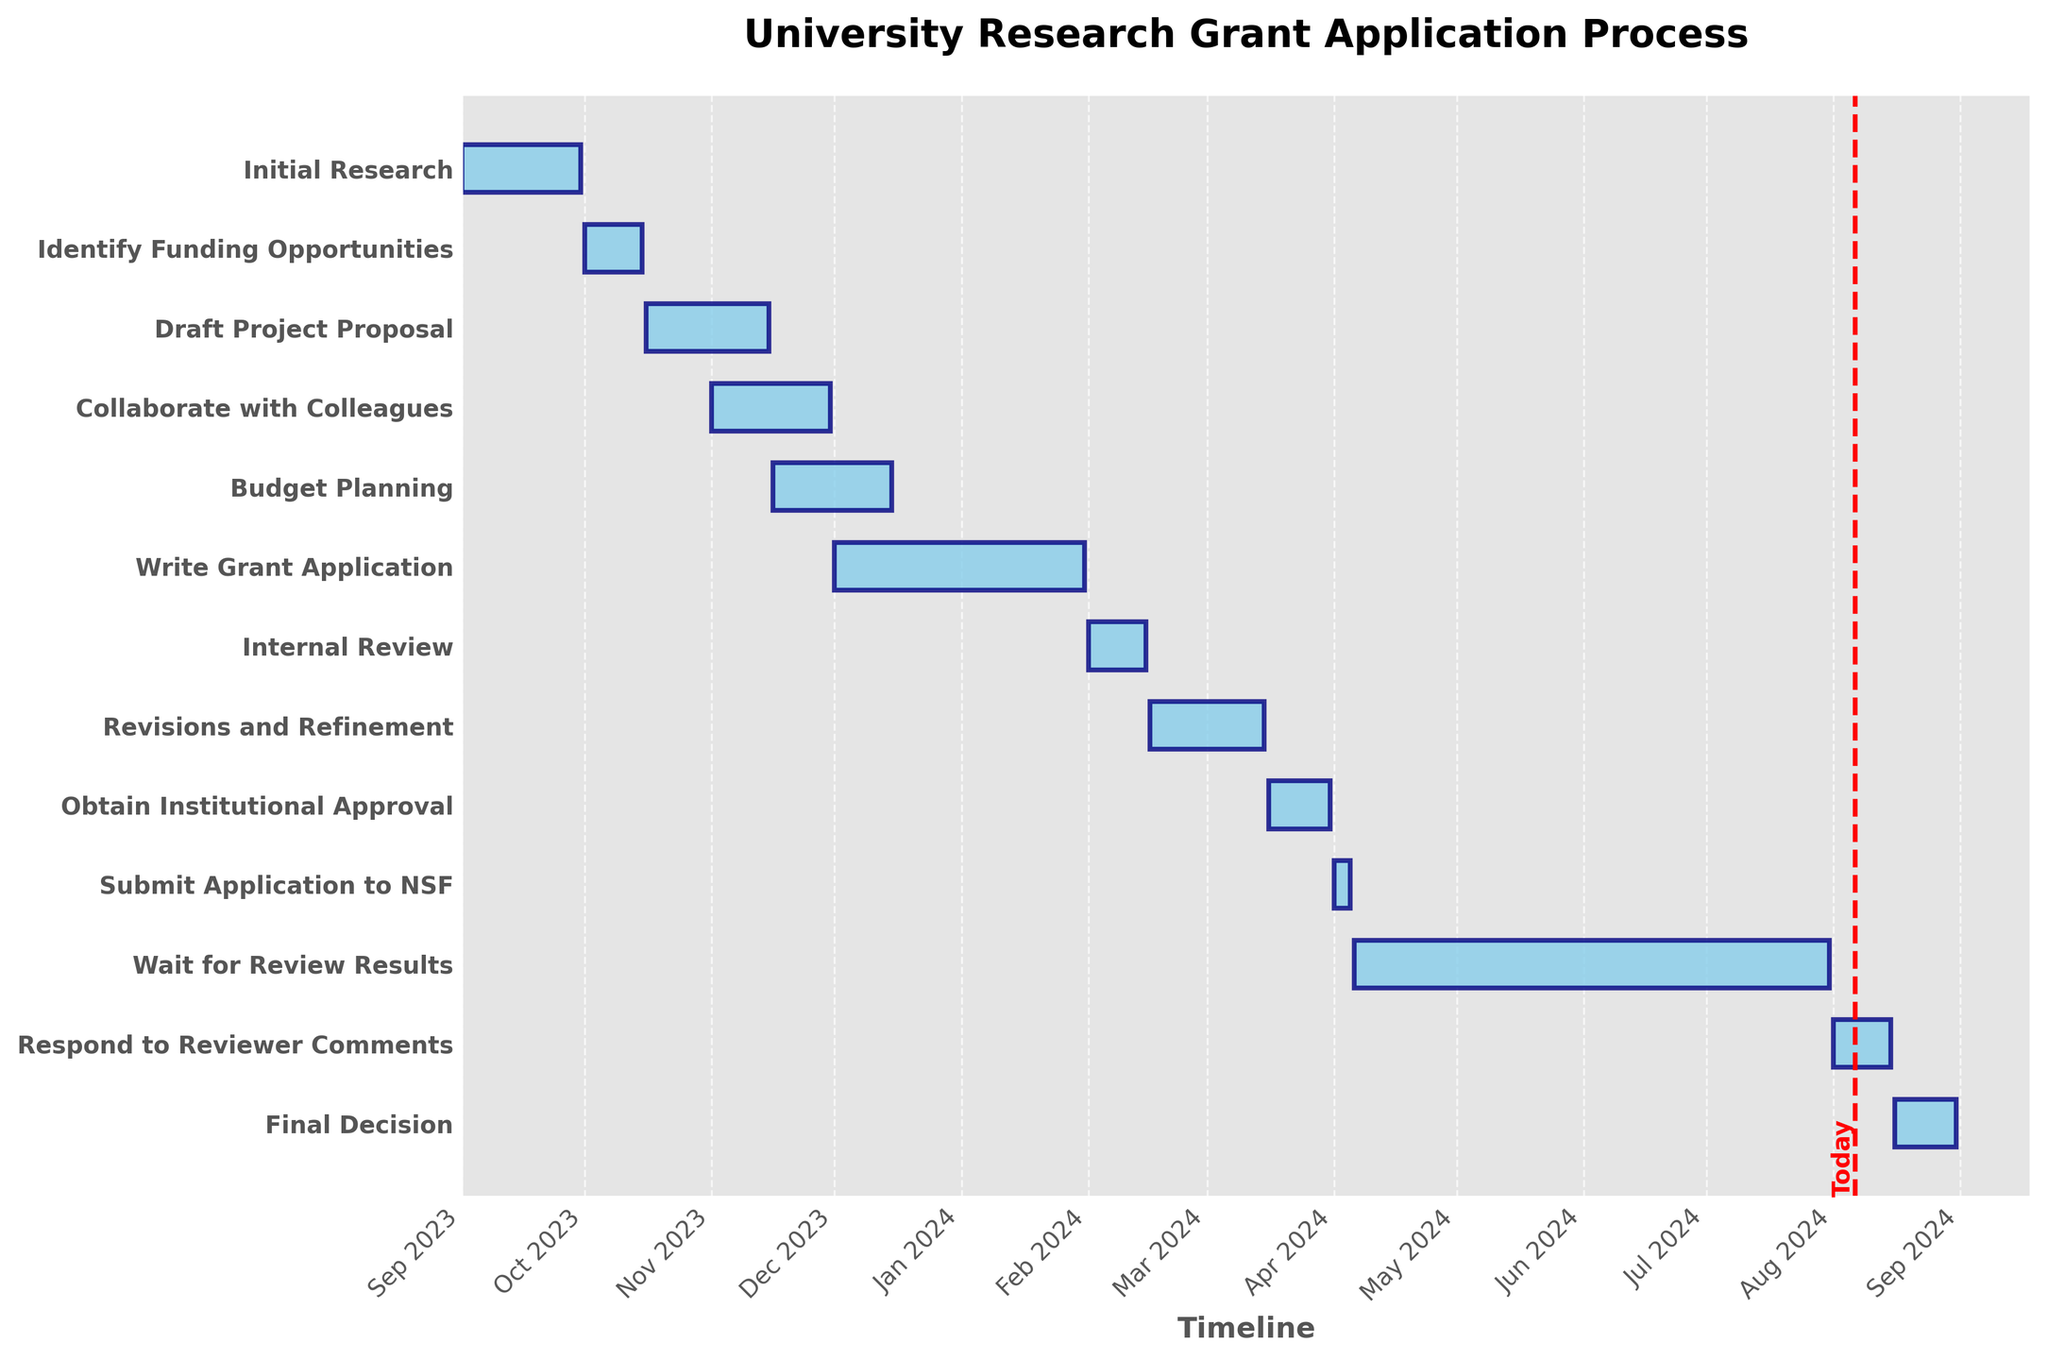What's the title of the Gantt chart? The title is displayed at the top center of the Gantt chart. By looking at the visual, you can read the title clearly.
Answer: University Research Grant Application Process Which task runs the longest? To determine the longest task, compare the horizontal length of the bars. The longest bar visually represents the duration from "Write Grant Application" which spans two months.
Answer: Write Grant Application When does the "Identify Funding Opportunities" task start and end? Examine the bar corresponding to the "Identify Funding Opportunities" task on the y-axis. The left edge of the bar indicates the start date, and the right edge indicates the end date. This specific bar starts on October 1, 2023, and ends on October 15, 2023.
Answer: October 1, 2023 - October 15, 2023 Which task overlaps with "Collaborate with Colleagues"? Identify tasks that have bars overlapping with "Collaborate with Colleagues." Both "Draft Project Proposal" and "Budget Planning" overlap with "Collaborate with Colleagues" based on the timeline.
Answer: Draft Project Proposal and Budget Planning Which task ends earliest? Look for the task with the bar ending closest to the chart's left side. The earliest ending task is "Identify Funding Opportunities," which ends on October 15, 2023.
Answer: Identify Funding Opportunities How long is the "Internal Review" stage? To determine the duration, look at the length of the bar corresponding to "Internal Review." It starts on February 1, 2024, and ends on February 15, 2024, making its duration 15 days.
Answer: 15 days What's the total duration for the "Budget Planning" and "Revisions and Refinement" tasks, combined? Calculate the duration of each task by subtracting the start date from the end date, then sum them up. "Budget Planning" runs from November 16, 2023, to December 15, 2023, lasting 30 days, and "Revisions and Refinement" runs from February 16, 2024, to March 15, 2024, also lasting 29 days. The combined duration is 30 + 29 = 59 days.
Answer: 59 days Which tasks occur after "Submit Application to NSF"? Find the tasks listed on the timeline after the "Submit Application to NSF" bar. These tasks are "Wait for Review Results," "Respond to Reviewer Comments," and "Final Decision."
Answer: Wait for Review Results, Respond to Reviewer Comments, and Final Decision How many tasks begin in November 2023? Count the bars on the Gantt chart that have their start date within the month of November 2023. The tasks "Collaborate with Colleagues," "Budget Planning," and "Draft Project Proposal" all begin in November 2023.
Answer: 3 tasks 